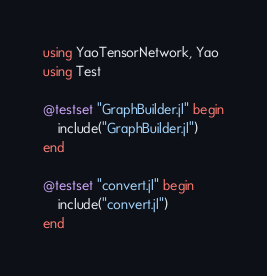<code> <loc_0><loc_0><loc_500><loc_500><_Julia_>using YaoTensorNetwork, Yao
using Test

@testset "GraphBuilder.jl" begin
    include("GraphBuilder.jl")
end

@testset "convert.jl" begin
    include("convert.jl")
end
</code> 